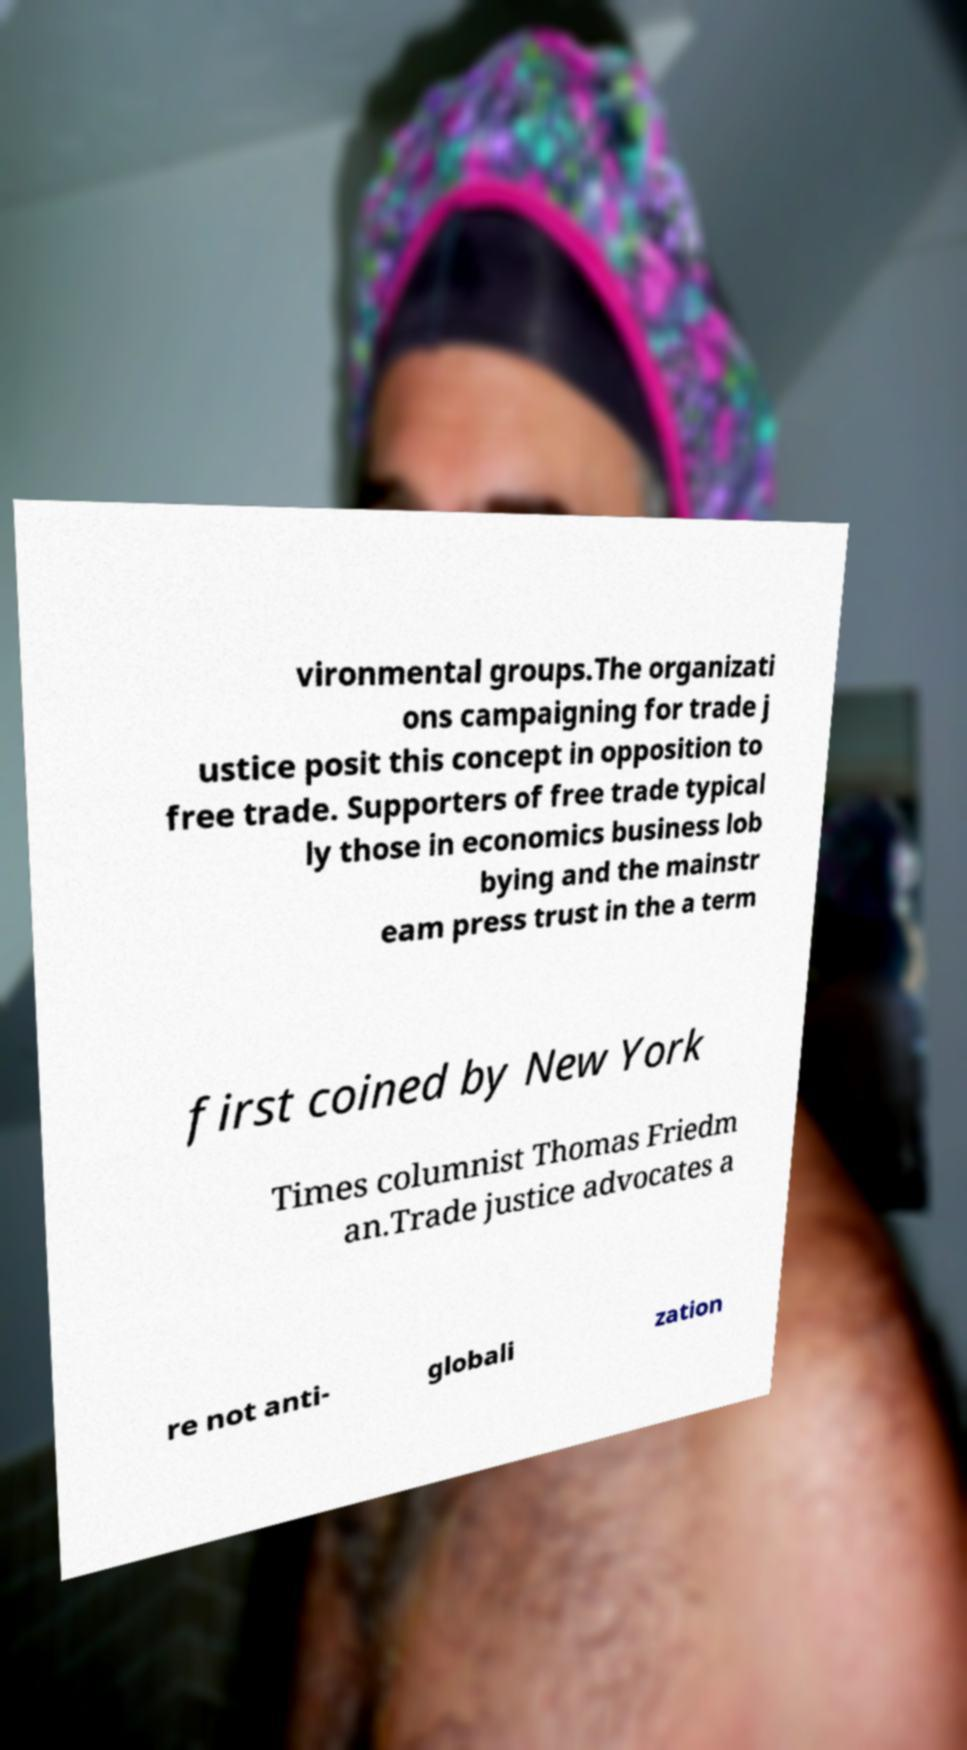Please read and relay the text visible in this image. What does it say? vironmental groups.The organizati ons campaigning for trade j ustice posit this concept in opposition to free trade. Supporters of free trade typical ly those in economics business lob bying and the mainstr eam press trust in the a term first coined by New York Times columnist Thomas Friedm an.Trade justice advocates a re not anti- globali zation 